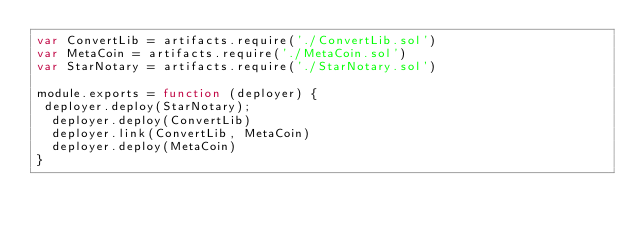Convert code to text. <code><loc_0><loc_0><loc_500><loc_500><_JavaScript_>var ConvertLib = artifacts.require('./ConvertLib.sol')
var MetaCoin = artifacts.require('./MetaCoin.sol')
var StarNotary = artifacts.require('./StarNotary.sol')

module.exports = function (deployer) {
 deployer.deploy(StarNotary);
  deployer.deploy(ConvertLib)
  deployer.link(ConvertLib, MetaCoin)
  deployer.deploy(MetaCoin)
}
</code> 